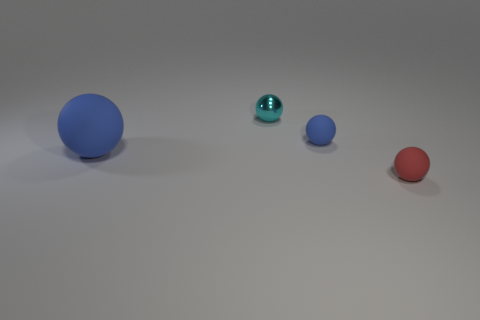What number of small blue rubber objects have the same shape as the small red object?
Make the answer very short. 1. Are there an equal number of small shiny objects that are in front of the small shiny ball and big blue spheres?
Make the answer very short. No. There is a metallic ball that is the same size as the red object; what color is it?
Provide a short and direct response. Cyan. Is there a tiny blue rubber object of the same shape as the small red rubber thing?
Provide a succinct answer. Yes. What material is the cyan sphere that is behind the blue sphere on the left side of the blue sphere right of the big blue sphere?
Keep it short and to the point. Metal. What color is the big rubber object?
Offer a terse response. Blue. What number of rubber objects are red spheres or small spheres?
Give a very brief answer. 2. Are there any other things that have the same material as the small cyan ball?
Keep it short and to the point. No. There is a blue thing that is left of the small cyan shiny thing that is right of the blue object that is on the left side of the tiny blue rubber ball; what size is it?
Your answer should be very brief. Large. There is a object that is both to the right of the cyan metal thing and behind the big matte sphere; what size is it?
Keep it short and to the point. Small. 